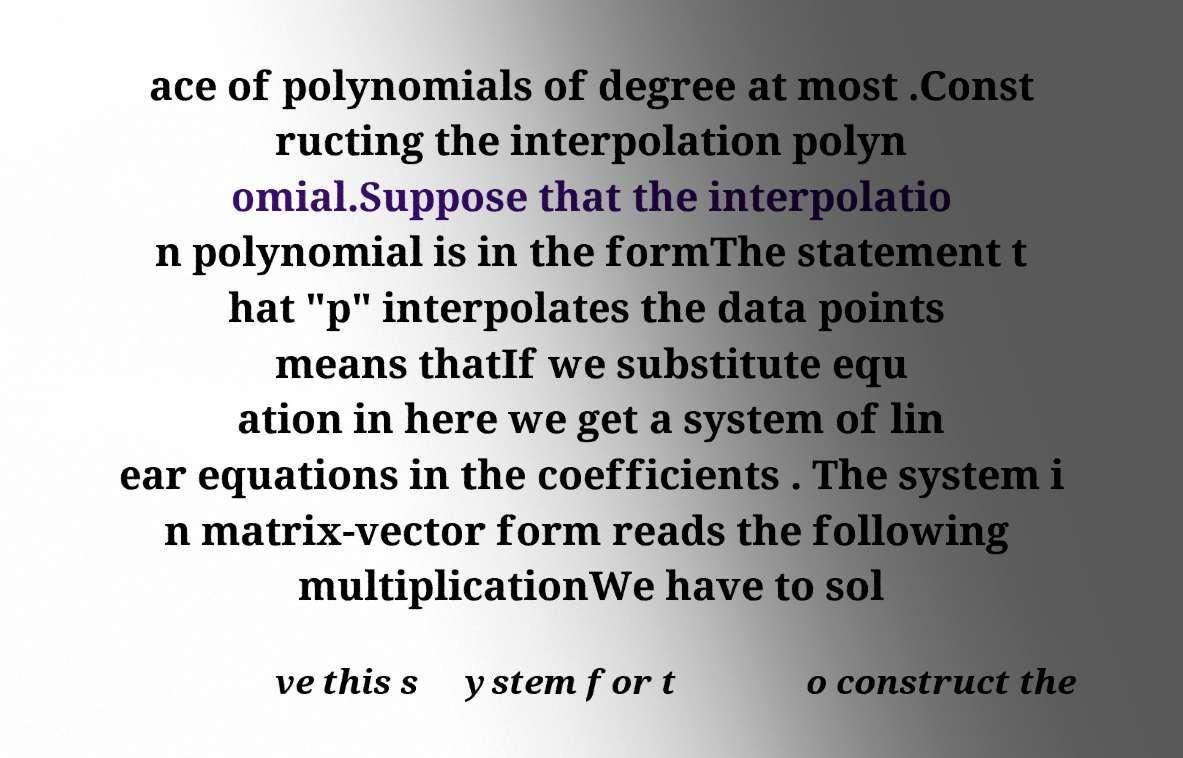Please identify and transcribe the text found in this image. ace of polynomials of degree at most .Const ructing the interpolation polyn omial.Suppose that the interpolatio n polynomial is in the formThe statement t hat "p" interpolates the data points means thatIf we substitute equ ation in here we get a system of lin ear equations in the coefficients . The system i n matrix-vector form reads the following multiplicationWe have to sol ve this s ystem for t o construct the 